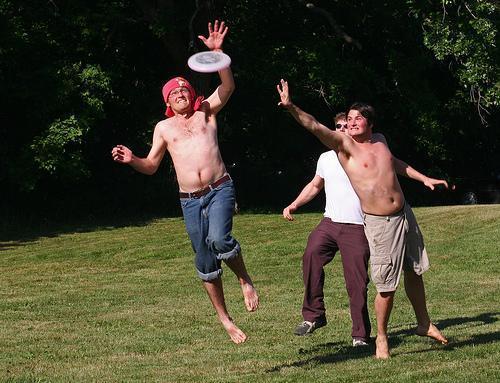How many frisbees are there?
Give a very brief answer. 1. 